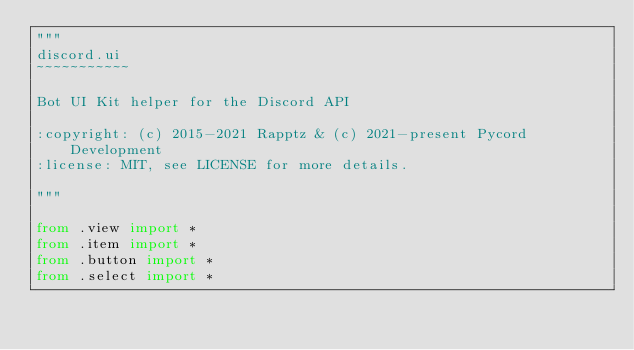<code> <loc_0><loc_0><loc_500><loc_500><_Python_>"""
discord.ui
~~~~~~~~~~~

Bot UI Kit helper for the Discord API

:copyright: (c) 2015-2021 Rapptz & (c) 2021-present Pycord Development
:license: MIT, see LICENSE for more details.

"""

from .view import *
from .item import *
from .button import *
from .select import *
</code> 